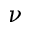<formula> <loc_0><loc_0><loc_500><loc_500>\nu</formula> 